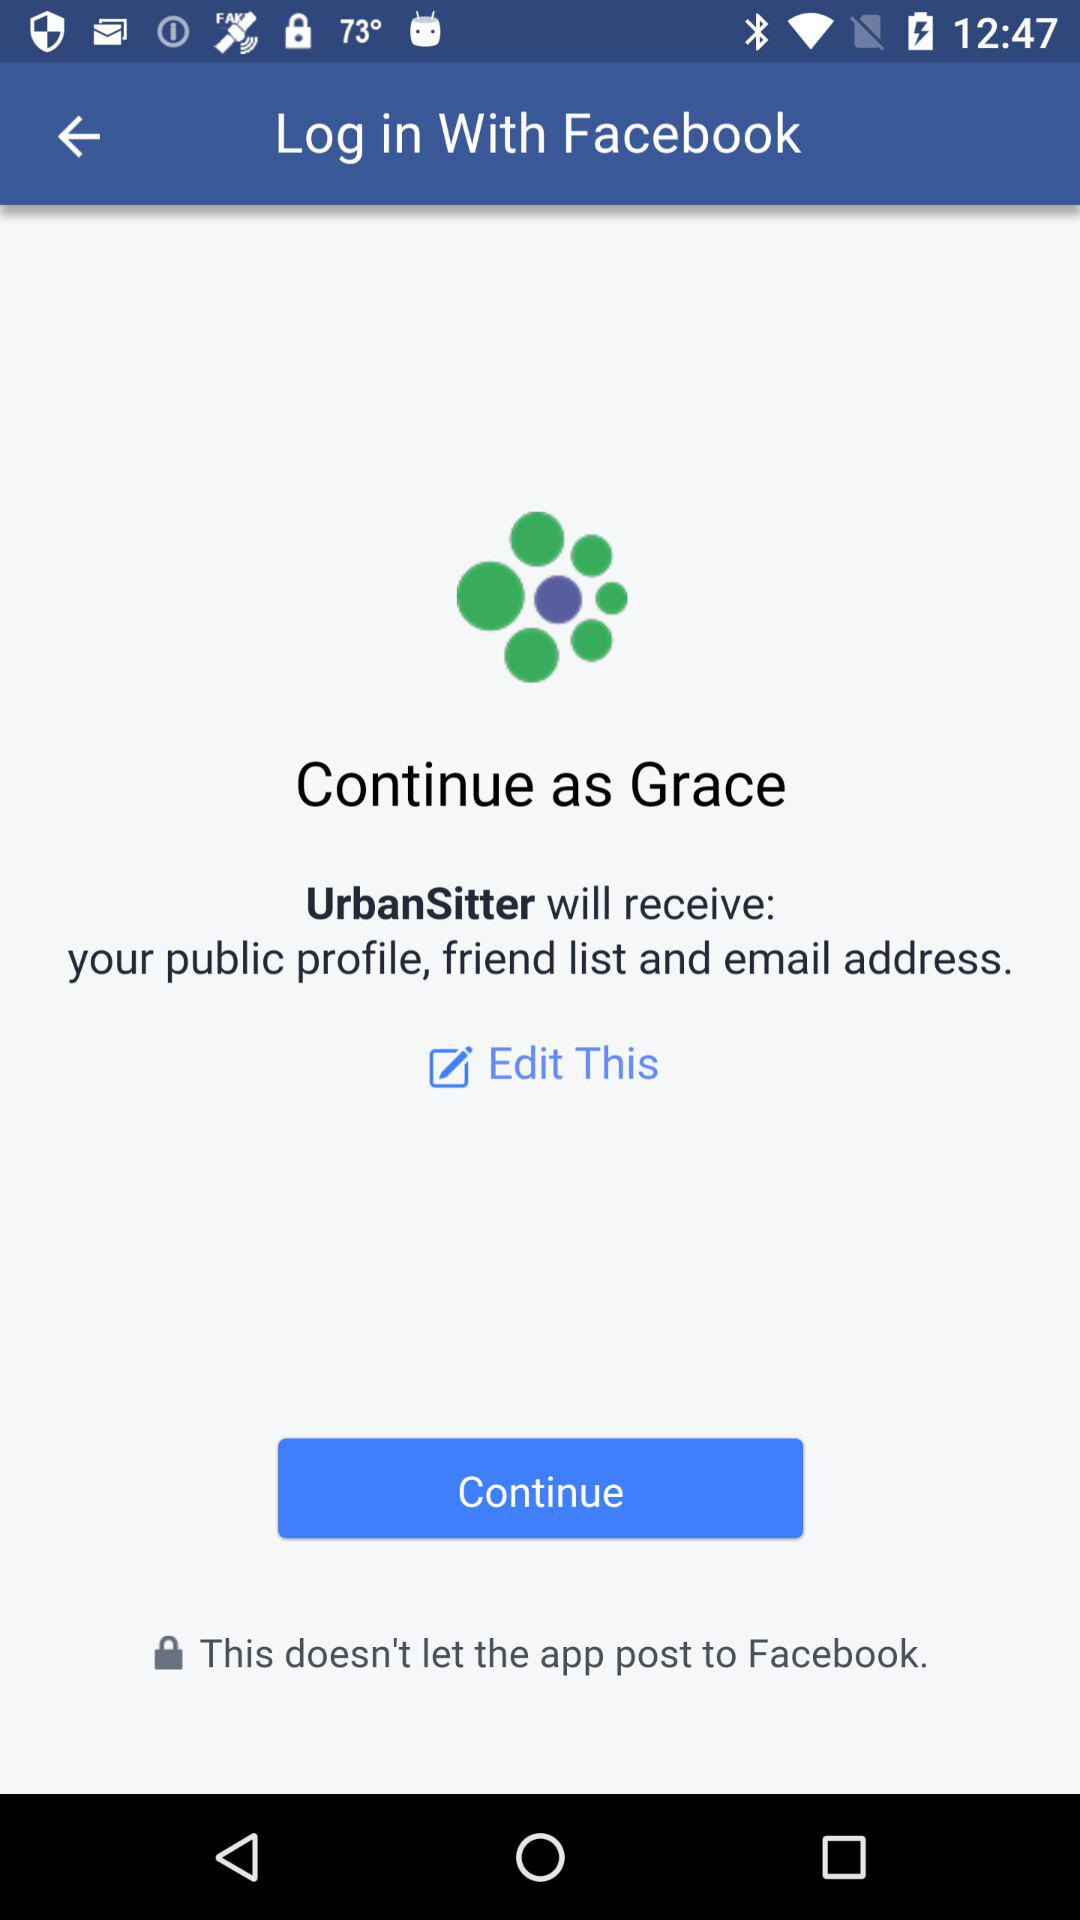What application is asking for permission? The application asking for permission is "UrbanSitter". 